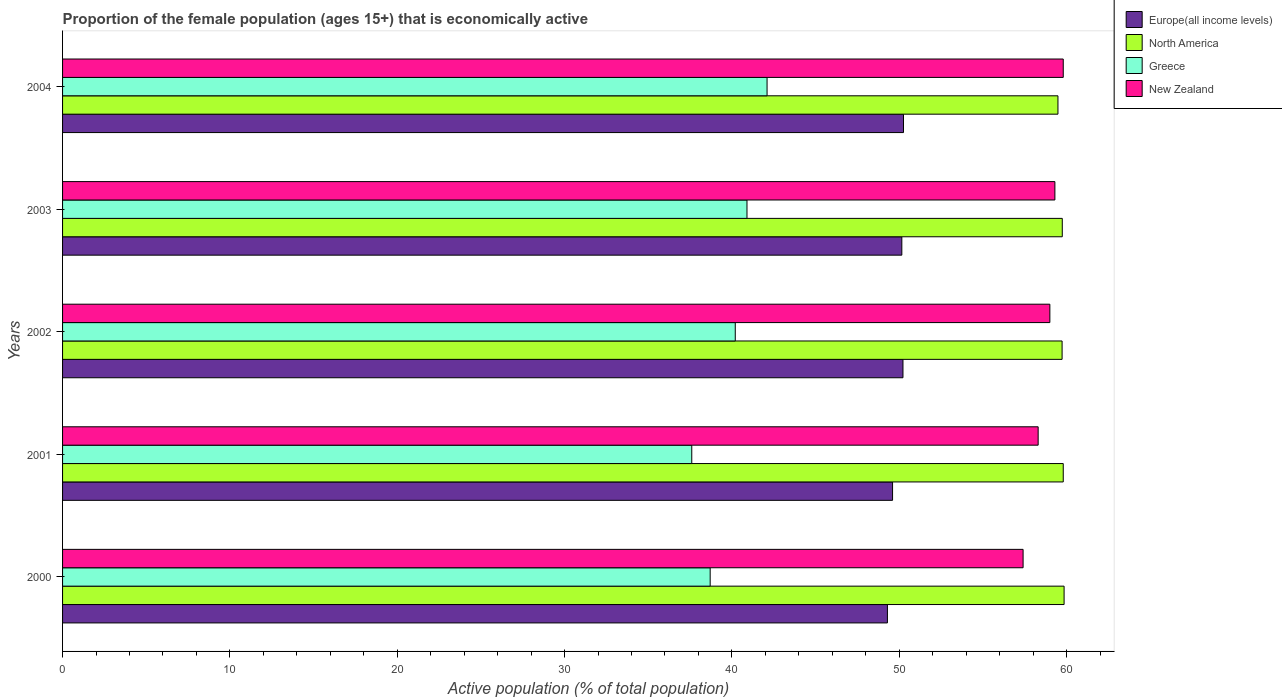How many different coloured bars are there?
Your answer should be compact. 4. How many groups of bars are there?
Make the answer very short. 5. How many bars are there on the 4th tick from the top?
Ensure brevity in your answer.  4. What is the proportion of the female population that is economically active in North America in 2001?
Your response must be concise. 59.8. Across all years, what is the maximum proportion of the female population that is economically active in New Zealand?
Your response must be concise. 59.8. Across all years, what is the minimum proportion of the female population that is economically active in New Zealand?
Offer a very short reply. 57.4. What is the total proportion of the female population that is economically active in North America in the graph?
Your answer should be compact. 298.61. What is the difference between the proportion of the female population that is economically active in Greece in 2000 and that in 2002?
Give a very brief answer. -1.5. What is the difference between the proportion of the female population that is economically active in Europe(all income levels) in 2004 and the proportion of the female population that is economically active in Greece in 2003?
Provide a succinct answer. 9.35. What is the average proportion of the female population that is economically active in Greece per year?
Provide a short and direct response. 39.9. In the year 2004, what is the difference between the proportion of the female population that is economically active in North America and proportion of the female population that is economically active in Greece?
Your answer should be very brief. 17.38. In how many years, is the proportion of the female population that is economically active in Greece greater than 20 %?
Make the answer very short. 5. What is the ratio of the proportion of the female population that is economically active in North America in 2000 to that in 2001?
Make the answer very short. 1. Is the proportion of the female population that is economically active in North America in 2001 less than that in 2003?
Offer a very short reply. No. What is the difference between the highest and the second highest proportion of the female population that is economically active in New Zealand?
Keep it short and to the point. 0.5. What is the difference between the highest and the lowest proportion of the female population that is economically active in New Zealand?
Provide a succinct answer. 2.4. In how many years, is the proportion of the female population that is economically active in Greece greater than the average proportion of the female population that is economically active in Greece taken over all years?
Make the answer very short. 3. Is the sum of the proportion of the female population that is economically active in Greece in 2001 and 2003 greater than the maximum proportion of the female population that is economically active in New Zealand across all years?
Your answer should be very brief. Yes. What does the 1st bar from the bottom in 2001 represents?
Provide a short and direct response. Europe(all income levels). How many bars are there?
Offer a terse response. 20. Are the values on the major ticks of X-axis written in scientific E-notation?
Give a very brief answer. No. Where does the legend appear in the graph?
Your response must be concise. Top right. How are the legend labels stacked?
Your response must be concise. Vertical. What is the title of the graph?
Offer a terse response. Proportion of the female population (ages 15+) that is economically active. Does "Mozambique" appear as one of the legend labels in the graph?
Your answer should be very brief. No. What is the label or title of the X-axis?
Your answer should be very brief. Active population (% of total population). What is the label or title of the Y-axis?
Make the answer very short. Years. What is the Active population (% of total population) of Europe(all income levels) in 2000?
Provide a succinct answer. 49.29. What is the Active population (% of total population) in North America in 2000?
Your response must be concise. 59.85. What is the Active population (% of total population) in Greece in 2000?
Offer a terse response. 38.7. What is the Active population (% of total population) of New Zealand in 2000?
Your answer should be compact. 57.4. What is the Active population (% of total population) of Europe(all income levels) in 2001?
Provide a succinct answer. 49.6. What is the Active population (% of total population) in North America in 2001?
Keep it short and to the point. 59.8. What is the Active population (% of total population) of Greece in 2001?
Make the answer very short. 37.6. What is the Active population (% of total population) of New Zealand in 2001?
Offer a terse response. 58.3. What is the Active population (% of total population) in Europe(all income levels) in 2002?
Your answer should be very brief. 50.22. What is the Active population (% of total population) in North America in 2002?
Offer a very short reply. 59.73. What is the Active population (% of total population) in Greece in 2002?
Your response must be concise. 40.2. What is the Active population (% of total population) in New Zealand in 2002?
Offer a very short reply. 59. What is the Active population (% of total population) in Europe(all income levels) in 2003?
Keep it short and to the point. 50.15. What is the Active population (% of total population) in North America in 2003?
Provide a short and direct response. 59.74. What is the Active population (% of total population) of Greece in 2003?
Offer a terse response. 40.9. What is the Active population (% of total population) in New Zealand in 2003?
Provide a short and direct response. 59.3. What is the Active population (% of total population) of Europe(all income levels) in 2004?
Ensure brevity in your answer.  50.25. What is the Active population (% of total population) of North America in 2004?
Your answer should be compact. 59.48. What is the Active population (% of total population) of Greece in 2004?
Offer a terse response. 42.1. What is the Active population (% of total population) of New Zealand in 2004?
Provide a short and direct response. 59.8. Across all years, what is the maximum Active population (% of total population) of Europe(all income levels)?
Make the answer very short. 50.25. Across all years, what is the maximum Active population (% of total population) of North America?
Provide a succinct answer. 59.85. Across all years, what is the maximum Active population (% of total population) in Greece?
Give a very brief answer. 42.1. Across all years, what is the maximum Active population (% of total population) in New Zealand?
Make the answer very short. 59.8. Across all years, what is the minimum Active population (% of total population) in Europe(all income levels)?
Give a very brief answer. 49.29. Across all years, what is the minimum Active population (% of total population) of North America?
Your answer should be compact. 59.48. Across all years, what is the minimum Active population (% of total population) of Greece?
Provide a short and direct response. 37.6. Across all years, what is the minimum Active population (% of total population) of New Zealand?
Provide a short and direct response. 57.4. What is the total Active population (% of total population) in Europe(all income levels) in the graph?
Keep it short and to the point. 249.52. What is the total Active population (% of total population) in North America in the graph?
Offer a terse response. 298.61. What is the total Active population (% of total population) of Greece in the graph?
Make the answer very short. 199.5. What is the total Active population (% of total population) in New Zealand in the graph?
Your answer should be very brief. 293.8. What is the difference between the Active population (% of total population) in Europe(all income levels) in 2000 and that in 2001?
Make the answer very short. -0.31. What is the difference between the Active population (% of total population) in North America in 2000 and that in 2001?
Keep it short and to the point. 0.05. What is the difference between the Active population (% of total population) in Europe(all income levels) in 2000 and that in 2002?
Your answer should be very brief. -0.93. What is the difference between the Active population (% of total population) in North America in 2000 and that in 2002?
Ensure brevity in your answer.  0.12. What is the difference between the Active population (% of total population) of Greece in 2000 and that in 2002?
Provide a succinct answer. -1.5. What is the difference between the Active population (% of total population) of New Zealand in 2000 and that in 2002?
Give a very brief answer. -1.6. What is the difference between the Active population (% of total population) of Europe(all income levels) in 2000 and that in 2003?
Keep it short and to the point. -0.86. What is the difference between the Active population (% of total population) in North America in 2000 and that in 2003?
Provide a succinct answer. 0.11. What is the difference between the Active population (% of total population) in Europe(all income levels) in 2000 and that in 2004?
Give a very brief answer. -0.96. What is the difference between the Active population (% of total population) in North America in 2000 and that in 2004?
Give a very brief answer. 0.37. What is the difference between the Active population (% of total population) in Europe(all income levels) in 2001 and that in 2002?
Offer a terse response. -0.62. What is the difference between the Active population (% of total population) of North America in 2001 and that in 2002?
Give a very brief answer. 0.07. What is the difference between the Active population (% of total population) in Greece in 2001 and that in 2002?
Offer a terse response. -2.6. What is the difference between the Active population (% of total population) in Europe(all income levels) in 2001 and that in 2003?
Provide a short and direct response. -0.55. What is the difference between the Active population (% of total population) of North America in 2001 and that in 2003?
Your answer should be very brief. 0.06. What is the difference between the Active population (% of total population) of Greece in 2001 and that in 2003?
Provide a short and direct response. -3.3. What is the difference between the Active population (% of total population) in Europe(all income levels) in 2001 and that in 2004?
Provide a succinct answer. -0.65. What is the difference between the Active population (% of total population) in North America in 2001 and that in 2004?
Make the answer very short. 0.32. What is the difference between the Active population (% of total population) in New Zealand in 2001 and that in 2004?
Offer a terse response. -1.5. What is the difference between the Active population (% of total population) of Europe(all income levels) in 2002 and that in 2003?
Make the answer very short. 0.07. What is the difference between the Active population (% of total population) in North America in 2002 and that in 2003?
Ensure brevity in your answer.  -0.01. What is the difference between the Active population (% of total population) of Europe(all income levels) in 2002 and that in 2004?
Make the answer very short. -0.03. What is the difference between the Active population (% of total population) in North America in 2002 and that in 2004?
Offer a very short reply. 0.25. What is the difference between the Active population (% of total population) in Greece in 2002 and that in 2004?
Your response must be concise. -1.9. What is the difference between the Active population (% of total population) in Europe(all income levels) in 2003 and that in 2004?
Keep it short and to the point. -0.1. What is the difference between the Active population (% of total population) of North America in 2003 and that in 2004?
Make the answer very short. 0.26. What is the difference between the Active population (% of total population) of Greece in 2003 and that in 2004?
Offer a very short reply. -1.2. What is the difference between the Active population (% of total population) of New Zealand in 2003 and that in 2004?
Make the answer very short. -0.5. What is the difference between the Active population (% of total population) of Europe(all income levels) in 2000 and the Active population (% of total population) of North America in 2001?
Keep it short and to the point. -10.51. What is the difference between the Active population (% of total population) in Europe(all income levels) in 2000 and the Active population (% of total population) in Greece in 2001?
Offer a terse response. 11.69. What is the difference between the Active population (% of total population) in Europe(all income levels) in 2000 and the Active population (% of total population) in New Zealand in 2001?
Your answer should be compact. -9.01. What is the difference between the Active population (% of total population) in North America in 2000 and the Active population (% of total population) in Greece in 2001?
Provide a short and direct response. 22.25. What is the difference between the Active population (% of total population) in North America in 2000 and the Active population (% of total population) in New Zealand in 2001?
Offer a very short reply. 1.55. What is the difference between the Active population (% of total population) of Greece in 2000 and the Active population (% of total population) of New Zealand in 2001?
Provide a short and direct response. -19.6. What is the difference between the Active population (% of total population) in Europe(all income levels) in 2000 and the Active population (% of total population) in North America in 2002?
Provide a succinct answer. -10.44. What is the difference between the Active population (% of total population) of Europe(all income levels) in 2000 and the Active population (% of total population) of Greece in 2002?
Provide a short and direct response. 9.09. What is the difference between the Active population (% of total population) of Europe(all income levels) in 2000 and the Active population (% of total population) of New Zealand in 2002?
Your answer should be compact. -9.71. What is the difference between the Active population (% of total population) in North America in 2000 and the Active population (% of total population) in Greece in 2002?
Give a very brief answer. 19.65. What is the difference between the Active population (% of total population) in North America in 2000 and the Active population (% of total population) in New Zealand in 2002?
Provide a succinct answer. 0.85. What is the difference between the Active population (% of total population) of Greece in 2000 and the Active population (% of total population) of New Zealand in 2002?
Provide a short and direct response. -20.3. What is the difference between the Active population (% of total population) of Europe(all income levels) in 2000 and the Active population (% of total population) of North America in 2003?
Offer a very short reply. -10.45. What is the difference between the Active population (% of total population) of Europe(all income levels) in 2000 and the Active population (% of total population) of Greece in 2003?
Offer a very short reply. 8.39. What is the difference between the Active population (% of total population) of Europe(all income levels) in 2000 and the Active population (% of total population) of New Zealand in 2003?
Make the answer very short. -10.01. What is the difference between the Active population (% of total population) of North America in 2000 and the Active population (% of total population) of Greece in 2003?
Provide a short and direct response. 18.95. What is the difference between the Active population (% of total population) in North America in 2000 and the Active population (% of total population) in New Zealand in 2003?
Offer a terse response. 0.55. What is the difference between the Active population (% of total population) of Greece in 2000 and the Active population (% of total population) of New Zealand in 2003?
Offer a very short reply. -20.6. What is the difference between the Active population (% of total population) of Europe(all income levels) in 2000 and the Active population (% of total population) of North America in 2004?
Offer a terse response. -10.19. What is the difference between the Active population (% of total population) in Europe(all income levels) in 2000 and the Active population (% of total population) in Greece in 2004?
Provide a succinct answer. 7.19. What is the difference between the Active population (% of total population) in Europe(all income levels) in 2000 and the Active population (% of total population) in New Zealand in 2004?
Your answer should be very brief. -10.51. What is the difference between the Active population (% of total population) in North America in 2000 and the Active population (% of total population) in Greece in 2004?
Your answer should be compact. 17.75. What is the difference between the Active population (% of total population) of North America in 2000 and the Active population (% of total population) of New Zealand in 2004?
Keep it short and to the point. 0.05. What is the difference between the Active population (% of total population) of Greece in 2000 and the Active population (% of total population) of New Zealand in 2004?
Provide a succinct answer. -21.1. What is the difference between the Active population (% of total population) of Europe(all income levels) in 2001 and the Active population (% of total population) of North America in 2002?
Your answer should be compact. -10.13. What is the difference between the Active population (% of total population) in Europe(all income levels) in 2001 and the Active population (% of total population) in Greece in 2002?
Ensure brevity in your answer.  9.4. What is the difference between the Active population (% of total population) of Europe(all income levels) in 2001 and the Active population (% of total population) of New Zealand in 2002?
Give a very brief answer. -9.4. What is the difference between the Active population (% of total population) of North America in 2001 and the Active population (% of total population) of Greece in 2002?
Keep it short and to the point. 19.6. What is the difference between the Active population (% of total population) of Greece in 2001 and the Active population (% of total population) of New Zealand in 2002?
Your response must be concise. -21.4. What is the difference between the Active population (% of total population) of Europe(all income levels) in 2001 and the Active population (% of total population) of North America in 2003?
Make the answer very short. -10.14. What is the difference between the Active population (% of total population) in Europe(all income levels) in 2001 and the Active population (% of total population) in Greece in 2003?
Your response must be concise. 8.7. What is the difference between the Active population (% of total population) of Europe(all income levels) in 2001 and the Active population (% of total population) of New Zealand in 2003?
Your answer should be compact. -9.7. What is the difference between the Active population (% of total population) of North America in 2001 and the Active population (% of total population) of Greece in 2003?
Give a very brief answer. 18.9. What is the difference between the Active population (% of total population) of North America in 2001 and the Active population (% of total population) of New Zealand in 2003?
Offer a terse response. 0.5. What is the difference between the Active population (% of total population) in Greece in 2001 and the Active population (% of total population) in New Zealand in 2003?
Keep it short and to the point. -21.7. What is the difference between the Active population (% of total population) in Europe(all income levels) in 2001 and the Active population (% of total population) in North America in 2004?
Offer a terse response. -9.88. What is the difference between the Active population (% of total population) of Europe(all income levels) in 2001 and the Active population (% of total population) of Greece in 2004?
Offer a terse response. 7.5. What is the difference between the Active population (% of total population) in Europe(all income levels) in 2001 and the Active population (% of total population) in New Zealand in 2004?
Your response must be concise. -10.2. What is the difference between the Active population (% of total population) of North America in 2001 and the Active population (% of total population) of New Zealand in 2004?
Your answer should be compact. 0. What is the difference between the Active population (% of total population) of Greece in 2001 and the Active population (% of total population) of New Zealand in 2004?
Give a very brief answer. -22.2. What is the difference between the Active population (% of total population) in Europe(all income levels) in 2002 and the Active population (% of total population) in North America in 2003?
Your answer should be very brief. -9.52. What is the difference between the Active population (% of total population) in Europe(all income levels) in 2002 and the Active population (% of total population) in Greece in 2003?
Give a very brief answer. 9.32. What is the difference between the Active population (% of total population) of Europe(all income levels) in 2002 and the Active population (% of total population) of New Zealand in 2003?
Offer a terse response. -9.08. What is the difference between the Active population (% of total population) in North America in 2002 and the Active population (% of total population) in Greece in 2003?
Give a very brief answer. 18.83. What is the difference between the Active population (% of total population) in North America in 2002 and the Active population (% of total population) in New Zealand in 2003?
Ensure brevity in your answer.  0.43. What is the difference between the Active population (% of total population) of Greece in 2002 and the Active population (% of total population) of New Zealand in 2003?
Your response must be concise. -19.1. What is the difference between the Active population (% of total population) in Europe(all income levels) in 2002 and the Active population (% of total population) in North America in 2004?
Your answer should be very brief. -9.26. What is the difference between the Active population (% of total population) in Europe(all income levels) in 2002 and the Active population (% of total population) in Greece in 2004?
Your answer should be compact. 8.12. What is the difference between the Active population (% of total population) of Europe(all income levels) in 2002 and the Active population (% of total population) of New Zealand in 2004?
Your response must be concise. -9.58. What is the difference between the Active population (% of total population) in North America in 2002 and the Active population (% of total population) in Greece in 2004?
Provide a short and direct response. 17.63. What is the difference between the Active population (% of total population) in North America in 2002 and the Active population (% of total population) in New Zealand in 2004?
Your answer should be compact. -0.07. What is the difference between the Active population (% of total population) of Greece in 2002 and the Active population (% of total population) of New Zealand in 2004?
Offer a very short reply. -19.6. What is the difference between the Active population (% of total population) of Europe(all income levels) in 2003 and the Active population (% of total population) of North America in 2004?
Your response must be concise. -9.33. What is the difference between the Active population (% of total population) of Europe(all income levels) in 2003 and the Active population (% of total population) of Greece in 2004?
Your answer should be compact. 8.05. What is the difference between the Active population (% of total population) of Europe(all income levels) in 2003 and the Active population (% of total population) of New Zealand in 2004?
Provide a succinct answer. -9.65. What is the difference between the Active population (% of total population) of North America in 2003 and the Active population (% of total population) of Greece in 2004?
Offer a very short reply. 17.64. What is the difference between the Active population (% of total population) of North America in 2003 and the Active population (% of total population) of New Zealand in 2004?
Make the answer very short. -0.06. What is the difference between the Active population (% of total population) of Greece in 2003 and the Active population (% of total population) of New Zealand in 2004?
Provide a succinct answer. -18.9. What is the average Active population (% of total population) of Europe(all income levels) per year?
Provide a short and direct response. 49.9. What is the average Active population (% of total population) in North America per year?
Make the answer very short. 59.72. What is the average Active population (% of total population) of Greece per year?
Offer a very short reply. 39.9. What is the average Active population (% of total population) in New Zealand per year?
Keep it short and to the point. 58.76. In the year 2000, what is the difference between the Active population (% of total population) of Europe(all income levels) and Active population (% of total population) of North America?
Your answer should be compact. -10.56. In the year 2000, what is the difference between the Active population (% of total population) in Europe(all income levels) and Active population (% of total population) in Greece?
Offer a very short reply. 10.59. In the year 2000, what is the difference between the Active population (% of total population) in Europe(all income levels) and Active population (% of total population) in New Zealand?
Offer a very short reply. -8.11. In the year 2000, what is the difference between the Active population (% of total population) in North America and Active population (% of total population) in Greece?
Keep it short and to the point. 21.15. In the year 2000, what is the difference between the Active population (% of total population) in North America and Active population (% of total population) in New Zealand?
Ensure brevity in your answer.  2.45. In the year 2000, what is the difference between the Active population (% of total population) of Greece and Active population (% of total population) of New Zealand?
Provide a succinct answer. -18.7. In the year 2001, what is the difference between the Active population (% of total population) in Europe(all income levels) and Active population (% of total population) in North America?
Your answer should be very brief. -10.2. In the year 2001, what is the difference between the Active population (% of total population) in Europe(all income levels) and Active population (% of total population) in Greece?
Provide a short and direct response. 12. In the year 2001, what is the difference between the Active population (% of total population) in Europe(all income levels) and Active population (% of total population) in New Zealand?
Your answer should be very brief. -8.7. In the year 2001, what is the difference between the Active population (% of total population) in North America and Active population (% of total population) in Greece?
Offer a terse response. 22.2. In the year 2001, what is the difference between the Active population (% of total population) in North America and Active population (% of total population) in New Zealand?
Your answer should be very brief. 1.5. In the year 2001, what is the difference between the Active population (% of total population) of Greece and Active population (% of total population) of New Zealand?
Your response must be concise. -20.7. In the year 2002, what is the difference between the Active population (% of total population) of Europe(all income levels) and Active population (% of total population) of North America?
Make the answer very short. -9.51. In the year 2002, what is the difference between the Active population (% of total population) of Europe(all income levels) and Active population (% of total population) of Greece?
Offer a very short reply. 10.02. In the year 2002, what is the difference between the Active population (% of total population) in Europe(all income levels) and Active population (% of total population) in New Zealand?
Offer a terse response. -8.78. In the year 2002, what is the difference between the Active population (% of total population) of North America and Active population (% of total population) of Greece?
Offer a very short reply. 19.53. In the year 2002, what is the difference between the Active population (% of total population) in North America and Active population (% of total population) in New Zealand?
Make the answer very short. 0.73. In the year 2002, what is the difference between the Active population (% of total population) of Greece and Active population (% of total population) of New Zealand?
Your answer should be very brief. -18.8. In the year 2003, what is the difference between the Active population (% of total population) of Europe(all income levels) and Active population (% of total population) of North America?
Your answer should be compact. -9.59. In the year 2003, what is the difference between the Active population (% of total population) of Europe(all income levels) and Active population (% of total population) of Greece?
Give a very brief answer. 9.25. In the year 2003, what is the difference between the Active population (% of total population) of Europe(all income levels) and Active population (% of total population) of New Zealand?
Keep it short and to the point. -9.15. In the year 2003, what is the difference between the Active population (% of total population) of North America and Active population (% of total population) of Greece?
Give a very brief answer. 18.84. In the year 2003, what is the difference between the Active population (% of total population) in North America and Active population (% of total population) in New Zealand?
Provide a short and direct response. 0.44. In the year 2003, what is the difference between the Active population (% of total population) in Greece and Active population (% of total population) in New Zealand?
Ensure brevity in your answer.  -18.4. In the year 2004, what is the difference between the Active population (% of total population) in Europe(all income levels) and Active population (% of total population) in North America?
Your response must be concise. -9.23. In the year 2004, what is the difference between the Active population (% of total population) of Europe(all income levels) and Active population (% of total population) of Greece?
Give a very brief answer. 8.15. In the year 2004, what is the difference between the Active population (% of total population) of Europe(all income levels) and Active population (% of total population) of New Zealand?
Offer a terse response. -9.55. In the year 2004, what is the difference between the Active population (% of total population) in North America and Active population (% of total population) in Greece?
Give a very brief answer. 17.38. In the year 2004, what is the difference between the Active population (% of total population) in North America and Active population (% of total population) in New Zealand?
Make the answer very short. -0.32. In the year 2004, what is the difference between the Active population (% of total population) of Greece and Active population (% of total population) of New Zealand?
Offer a very short reply. -17.7. What is the ratio of the Active population (% of total population) of Europe(all income levels) in 2000 to that in 2001?
Keep it short and to the point. 0.99. What is the ratio of the Active population (% of total population) in Greece in 2000 to that in 2001?
Make the answer very short. 1.03. What is the ratio of the Active population (% of total population) in New Zealand in 2000 to that in 2001?
Your answer should be very brief. 0.98. What is the ratio of the Active population (% of total population) in Europe(all income levels) in 2000 to that in 2002?
Give a very brief answer. 0.98. What is the ratio of the Active population (% of total population) in North America in 2000 to that in 2002?
Give a very brief answer. 1. What is the ratio of the Active population (% of total population) of Greece in 2000 to that in 2002?
Offer a very short reply. 0.96. What is the ratio of the Active population (% of total population) in New Zealand in 2000 to that in 2002?
Ensure brevity in your answer.  0.97. What is the ratio of the Active population (% of total population) in Europe(all income levels) in 2000 to that in 2003?
Give a very brief answer. 0.98. What is the ratio of the Active population (% of total population) of Greece in 2000 to that in 2003?
Your answer should be compact. 0.95. What is the ratio of the Active population (% of total population) of Europe(all income levels) in 2000 to that in 2004?
Offer a very short reply. 0.98. What is the ratio of the Active population (% of total population) of Greece in 2000 to that in 2004?
Ensure brevity in your answer.  0.92. What is the ratio of the Active population (% of total population) of New Zealand in 2000 to that in 2004?
Your answer should be very brief. 0.96. What is the ratio of the Active population (% of total population) in Europe(all income levels) in 2001 to that in 2002?
Your response must be concise. 0.99. What is the ratio of the Active population (% of total population) of North America in 2001 to that in 2002?
Offer a very short reply. 1. What is the ratio of the Active population (% of total population) in Greece in 2001 to that in 2002?
Keep it short and to the point. 0.94. What is the ratio of the Active population (% of total population) of New Zealand in 2001 to that in 2002?
Offer a very short reply. 0.99. What is the ratio of the Active population (% of total population) of North America in 2001 to that in 2003?
Offer a terse response. 1. What is the ratio of the Active population (% of total population) in Greece in 2001 to that in 2003?
Provide a short and direct response. 0.92. What is the ratio of the Active population (% of total population) in New Zealand in 2001 to that in 2003?
Your response must be concise. 0.98. What is the ratio of the Active population (% of total population) of Greece in 2001 to that in 2004?
Keep it short and to the point. 0.89. What is the ratio of the Active population (% of total population) in New Zealand in 2001 to that in 2004?
Your answer should be very brief. 0.97. What is the ratio of the Active population (% of total population) of Europe(all income levels) in 2002 to that in 2003?
Provide a short and direct response. 1. What is the ratio of the Active population (% of total population) in Greece in 2002 to that in 2003?
Your answer should be very brief. 0.98. What is the ratio of the Active population (% of total population) of Greece in 2002 to that in 2004?
Provide a succinct answer. 0.95. What is the ratio of the Active population (% of total population) in New Zealand in 2002 to that in 2004?
Give a very brief answer. 0.99. What is the ratio of the Active population (% of total population) of Europe(all income levels) in 2003 to that in 2004?
Your answer should be very brief. 1. What is the ratio of the Active population (% of total population) of North America in 2003 to that in 2004?
Provide a short and direct response. 1. What is the ratio of the Active population (% of total population) in Greece in 2003 to that in 2004?
Offer a very short reply. 0.97. What is the difference between the highest and the second highest Active population (% of total population) of Europe(all income levels)?
Offer a very short reply. 0.03. What is the difference between the highest and the second highest Active population (% of total population) of North America?
Offer a very short reply. 0.05. What is the difference between the highest and the second highest Active population (% of total population) in Greece?
Keep it short and to the point. 1.2. What is the difference between the highest and the second highest Active population (% of total population) of New Zealand?
Provide a short and direct response. 0.5. What is the difference between the highest and the lowest Active population (% of total population) in Europe(all income levels)?
Your answer should be compact. 0.96. What is the difference between the highest and the lowest Active population (% of total population) in North America?
Provide a succinct answer. 0.37. 